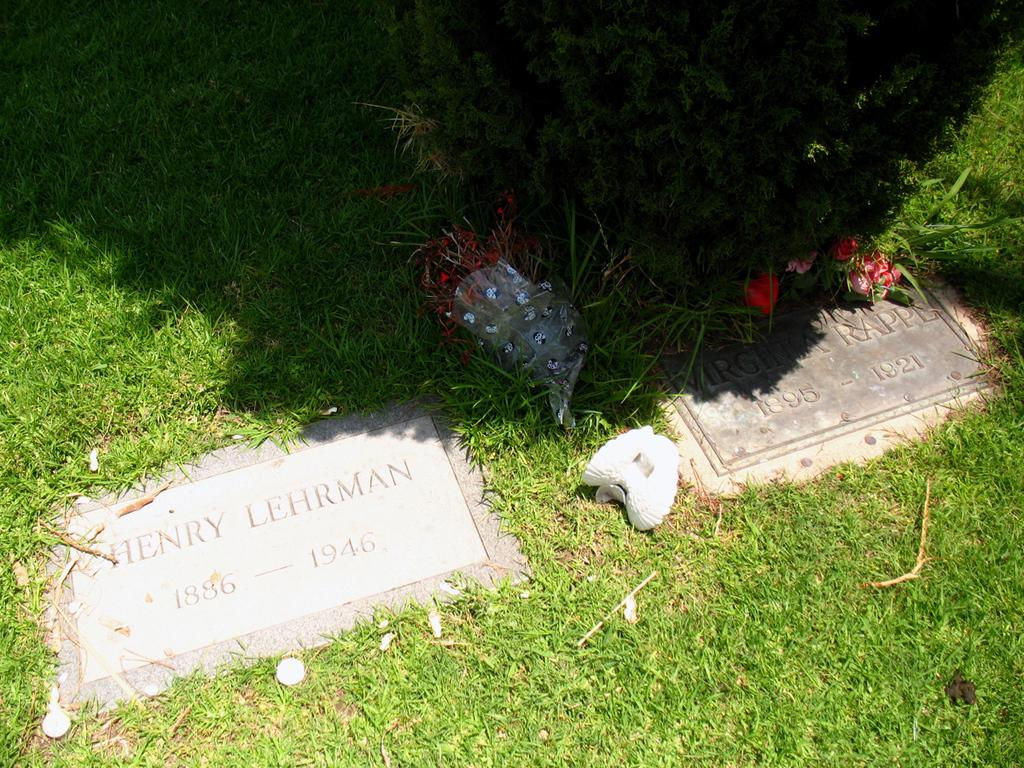What type of surface is visible in the image? There is a grass surface in the image. What can be seen on the grass surface? There are two grave tiles on the grass surface. What information is provided on the grave tiles? The grave tiles have names on them. What is present near the grave tiles? There are flower petals and a plant near the grave tiles. How many trees are visible in the image? There are no trees visible in the image. What type of box is used to store the flower petals in the image? There is no box present in the image; the flower petals are scattered near the grave tiles. 